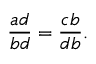Convert formula to latex. <formula><loc_0><loc_0><loc_500><loc_500>{ \frac { a d } { b d } } = { \frac { c b } { d b } } .</formula> 